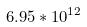<formula> <loc_0><loc_0><loc_500><loc_500>6 . 9 5 * 1 0 ^ { 1 2 }</formula> 